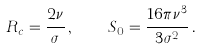<formula> <loc_0><loc_0><loc_500><loc_500>R _ { c } = \frac { 2 \nu } { \sigma } \, , \quad S _ { 0 } = \frac { 1 6 \pi \nu ^ { 3 } } { 3 \sigma ^ { 2 } } \, .</formula> 